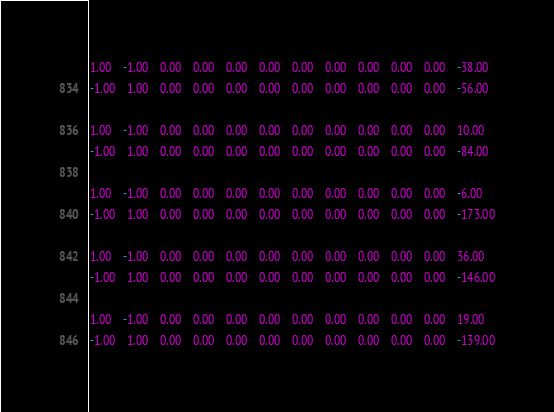<code> <loc_0><loc_0><loc_500><loc_500><_Matlab_>1.00	-1.00	0.00	0.00	0.00	0.00	0.00	0.00	0.00	0.00	0.00	-38.00
-1.00	1.00	0.00	0.00	0.00	0.00	0.00	0.00	0.00	0.00	0.00	-56.00

1.00	-1.00	0.00	0.00	0.00	0.00	0.00	0.00	0.00	0.00	0.00	10.00
-1.00	1.00	0.00	0.00	0.00	0.00	0.00	0.00	0.00	0.00	0.00	-84.00

1.00	-1.00	0.00	0.00	0.00	0.00	0.00	0.00	0.00	0.00	0.00	-6.00
-1.00	1.00	0.00	0.00	0.00	0.00	0.00	0.00	0.00	0.00	0.00	-173.00

1.00	-1.00	0.00	0.00	0.00	0.00	0.00	0.00	0.00	0.00	0.00	36.00
-1.00	1.00	0.00	0.00	0.00	0.00	0.00	0.00	0.00	0.00	0.00	-146.00

1.00	-1.00	0.00	0.00	0.00	0.00	0.00	0.00	0.00	0.00	0.00	19.00
-1.00	1.00	0.00	0.00	0.00	0.00	0.00	0.00	0.00	0.00	0.00	-139.00
</code> 